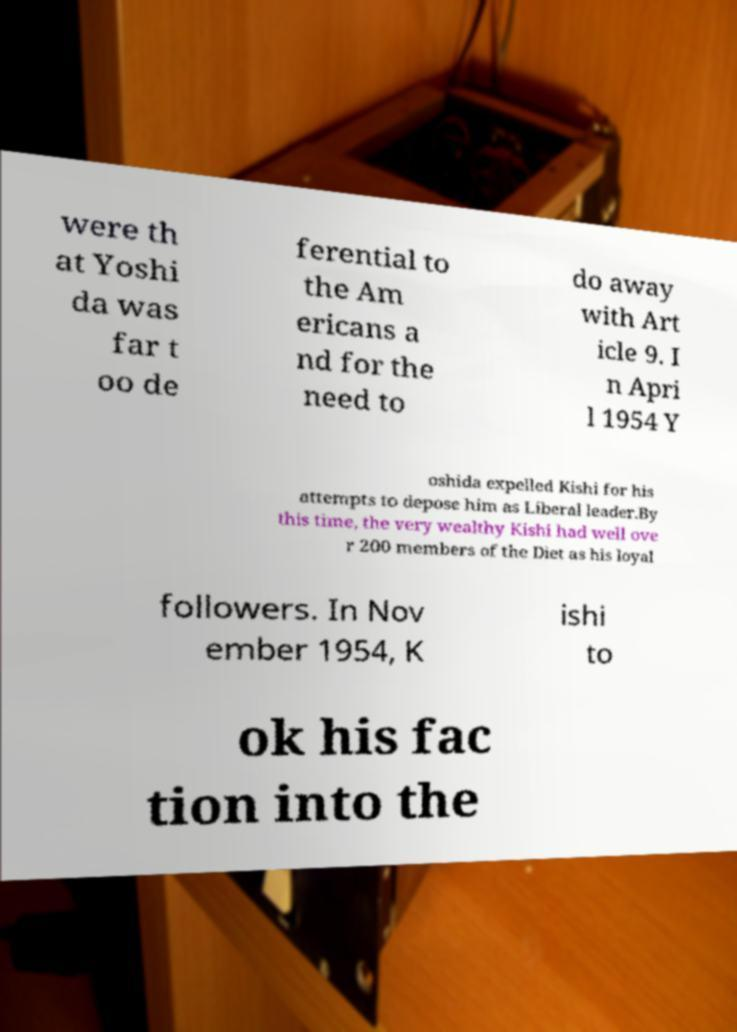Please identify and transcribe the text found in this image. were th at Yoshi da was far t oo de ferential to the Am ericans a nd for the need to do away with Art icle 9. I n Apri l 1954 Y oshida expelled Kishi for his attempts to depose him as Liberal leader.By this time, the very wealthy Kishi had well ove r 200 members of the Diet as his loyal followers. In Nov ember 1954, K ishi to ok his fac tion into the 